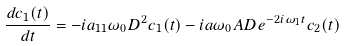<formula> <loc_0><loc_0><loc_500><loc_500>\frac { d c _ { 1 } ( t ) } { d t } = - i a _ { 1 1 } \omega _ { 0 } D ^ { 2 } c _ { 1 } ( t ) - i a \omega _ { 0 } A D e ^ { - 2 i \omega _ { 1 } t } c _ { 2 } ( t )</formula> 